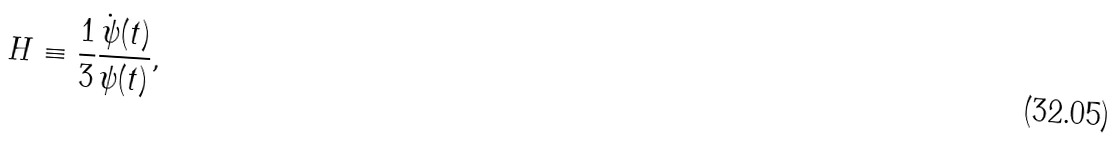Convert formula to latex. <formula><loc_0><loc_0><loc_500><loc_500>H \equiv \frac { 1 } { 3 } \frac { \dot { \psi } ( t ) } { \psi ( t ) } ,</formula> 